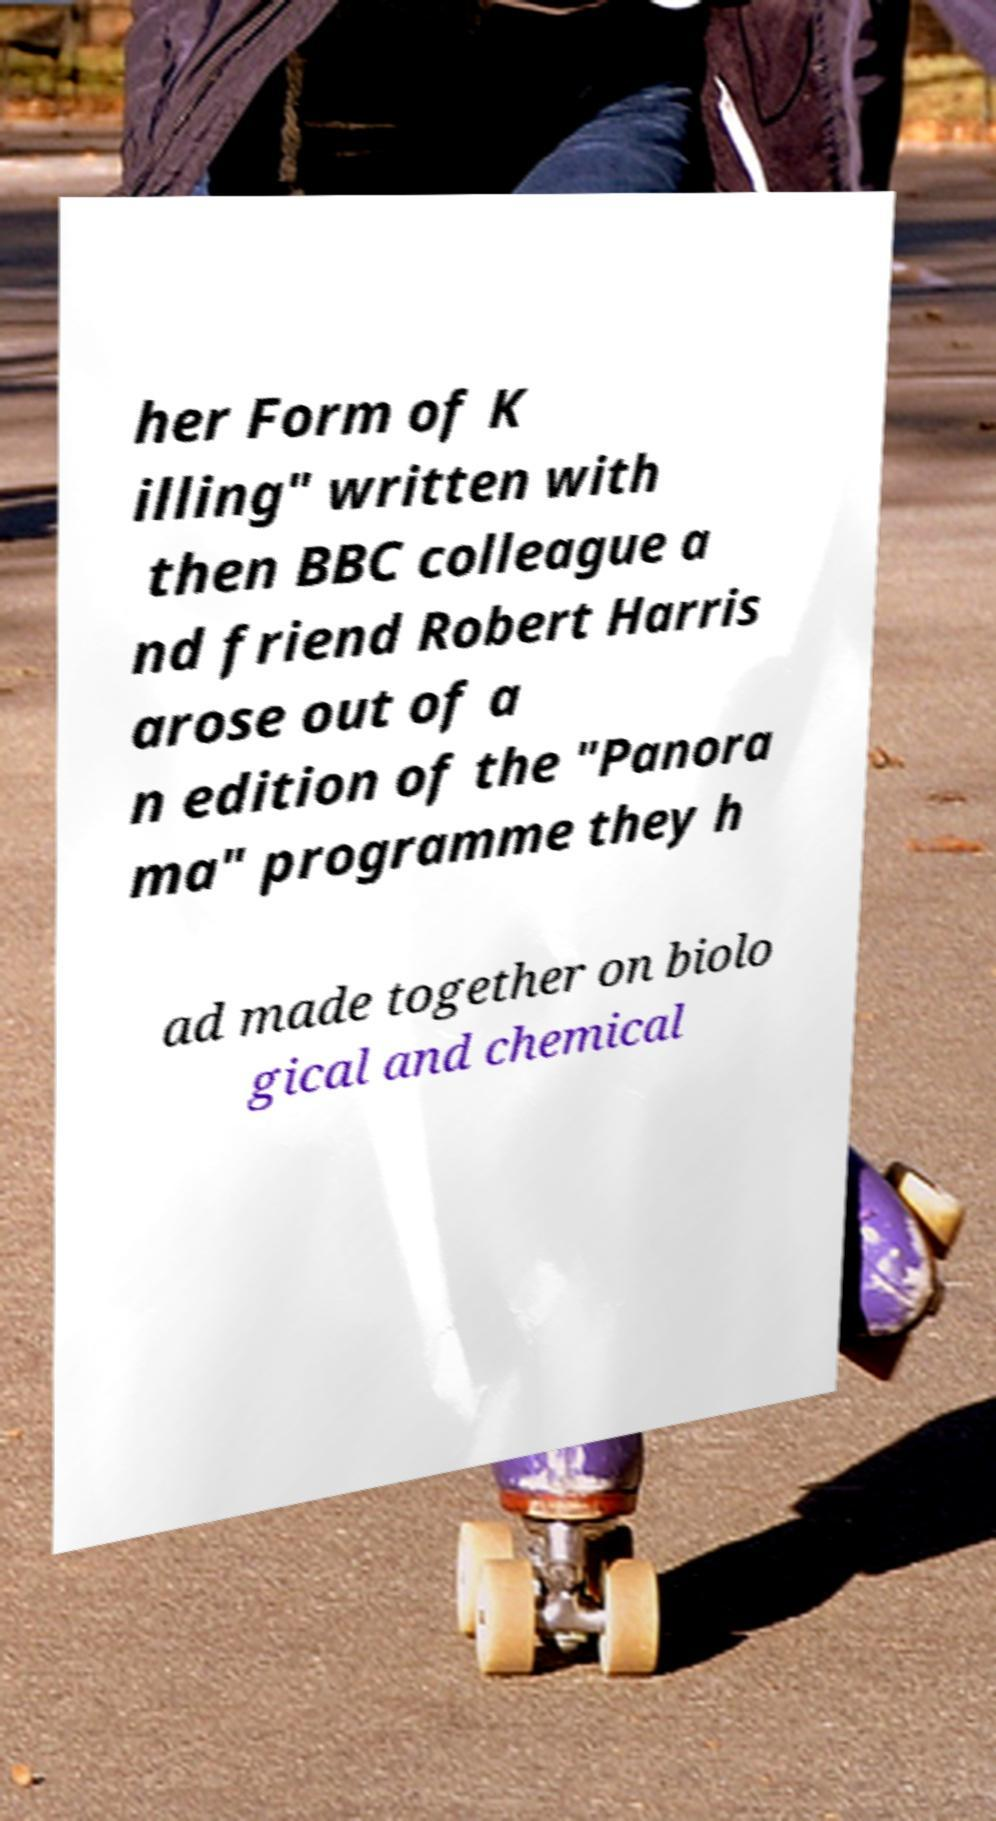There's text embedded in this image that I need extracted. Can you transcribe it verbatim? her Form of K illing" written with then BBC colleague a nd friend Robert Harris arose out of a n edition of the "Panora ma" programme they h ad made together on biolo gical and chemical 